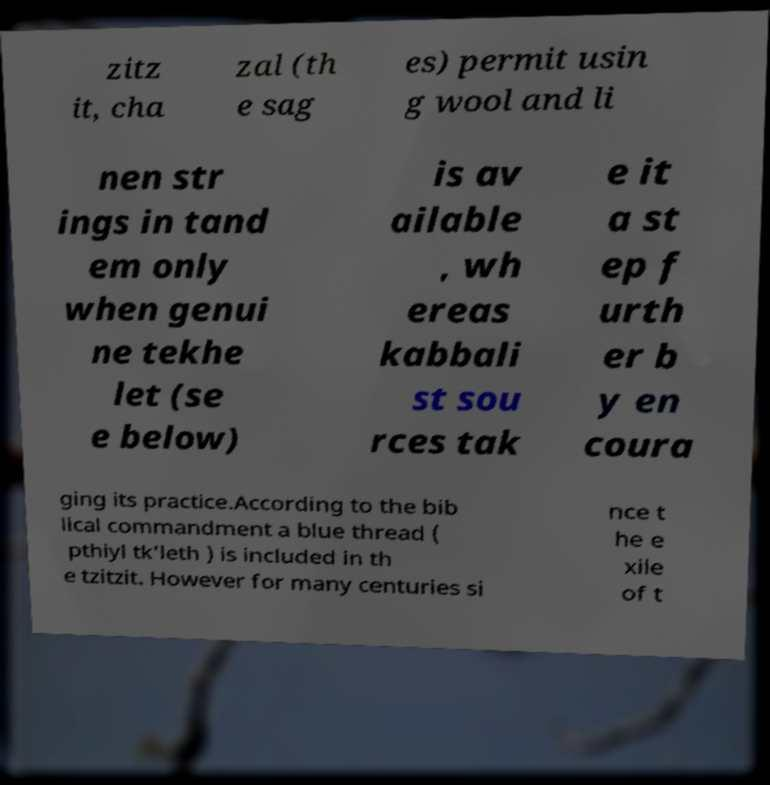What messages or text are displayed in this image? I need them in a readable, typed format. zitz it, cha zal (th e sag es) permit usin g wool and li nen str ings in tand em only when genui ne tekhe let (se e below) is av ailable , wh ereas kabbali st sou rces tak e it a st ep f urth er b y en coura ging its practice.According to the bib lical commandment a blue thread ( pthiyl tk'leth ) is included in th e tzitzit. However for many centuries si nce t he e xile of t 